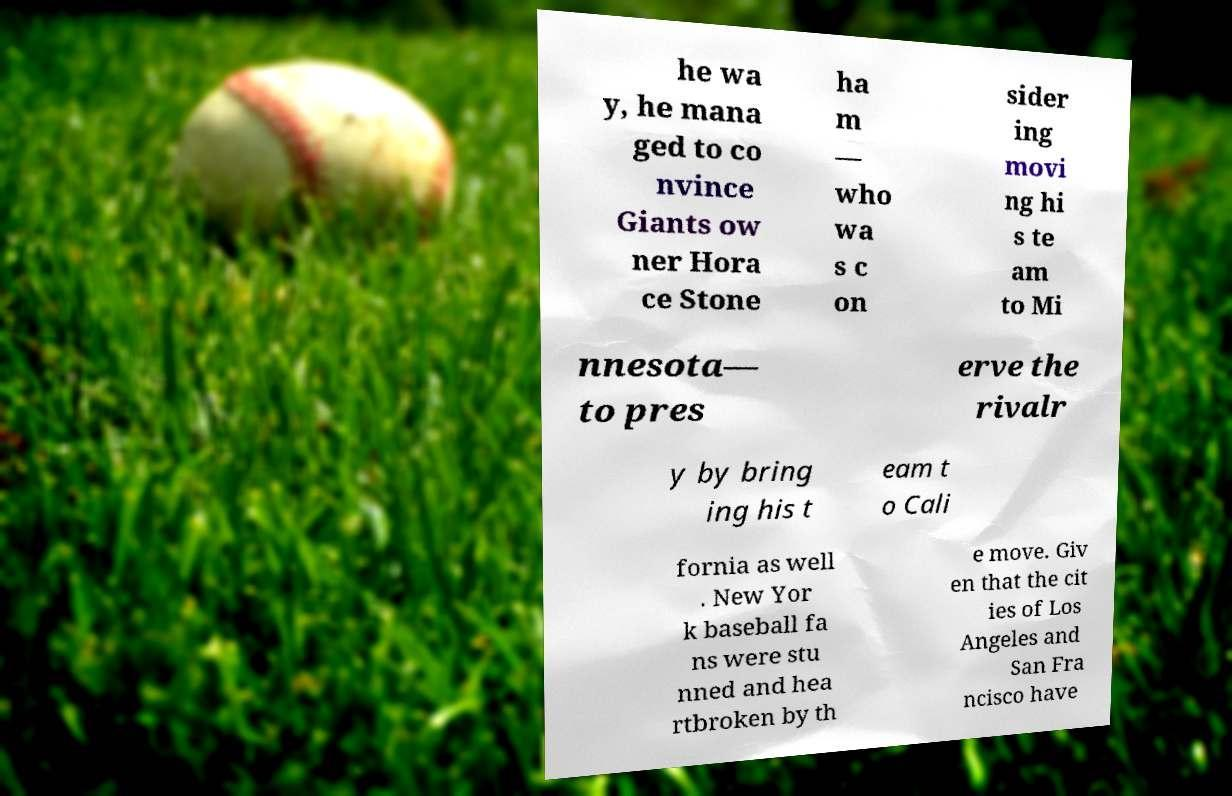There's text embedded in this image that I need extracted. Can you transcribe it verbatim? he wa y, he mana ged to co nvince Giants ow ner Hora ce Stone ha m — who wa s c on sider ing movi ng hi s te am to Mi nnesota— to pres erve the rivalr y by bring ing his t eam t o Cali fornia as well . New Yor k baseball fa ns were stu nned and hea rtbroken by th e move. Giv en that the cit ies of Los Angeles and San Fra ncisco have 